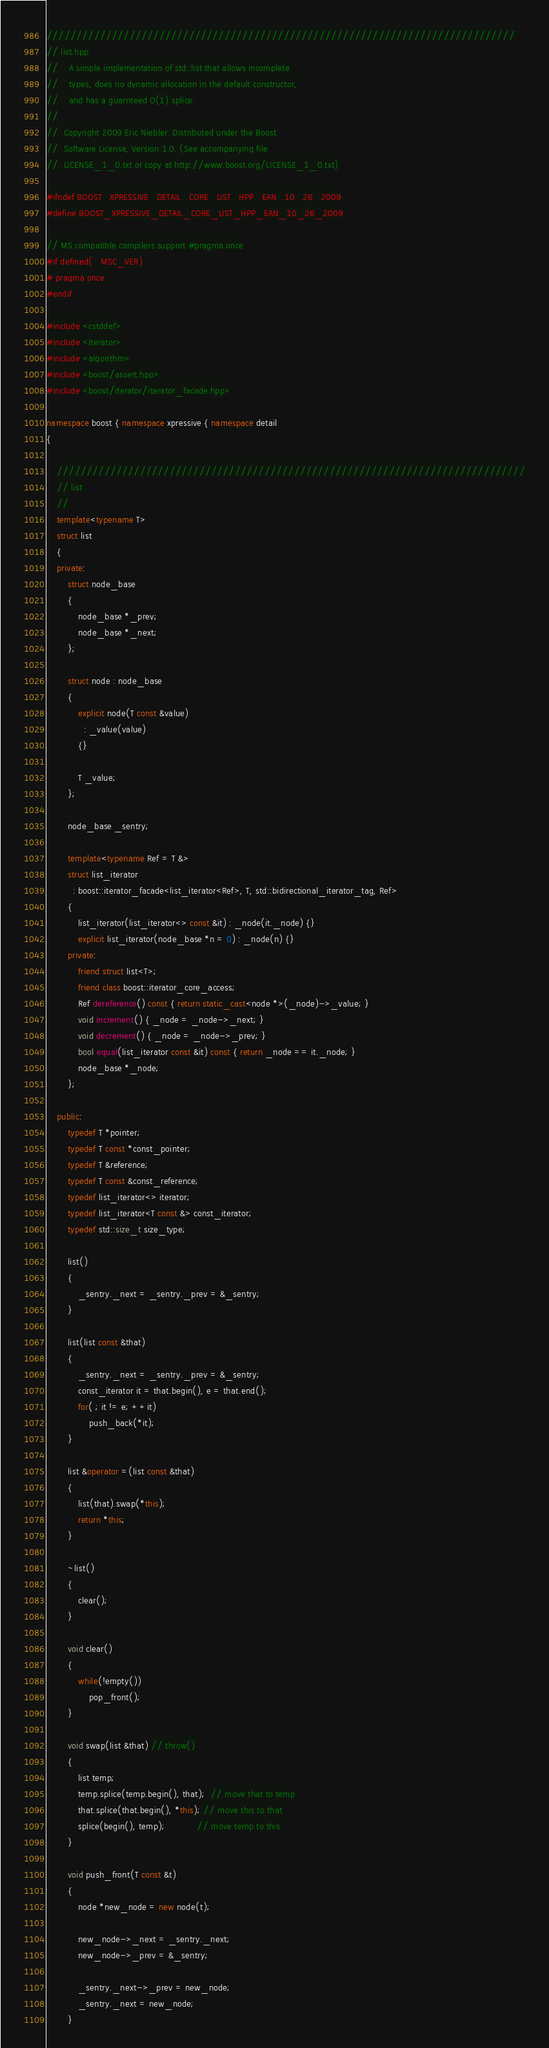<code> <loc_0><loc_0><loc_500><loc_500><_C++_>///////////////////////////////////////////////////////////////////////////////
// list.hpp
//    A simple implementation of std::list that allows incomplete
//    types, does no dynamic allocation in the default constructor,
//    and has a guarnteed O(1) splice.
//
//  Copyright 2009 Eric Niebler. Distributed under the Boost
//  Software License, Version 1.0. (See accompanying file
//  LICENSE_1_0.txt or copy at http://www.boost.org/LICENSE_1_0.txt)

#ifndef BOOST_XPRESSIVE_DETAIL_CORE_LIST_HPP_EAN_10_26_2009
#define BOOST_XPRESSIVE_DETAIL_CORE_LIST_HPP_EAN_10_26_2009

// MS compatible compilers support #pragma once
#if defined(_MSC_VER)
# pragma once
#endif

#include <cstddef>
#include <iterator>
#include <algorithm>
#include <boost/assert.hpp>
#include <boost/iterator/iterator_facade.hpp>

namespace boost { namespace xpressive { namespace detail
{

    ///////////////////////////////////////////////////////////////////////////////
    // list
    //
    template<typename T>
    struct list
    {
    private:
        struct node_base
        {
            node_base *_prev;
            node_base *_next;
        };

        struct node : node_base
        {
            explicit node(T const &value)
              : _value(value)
            {}

            T _value;
        };

        node_base _sentry;

        template<typename Ref = T &>
        struct list_iterator
          : boost::iterator_facade<list_iterator<Ref>, T, std::bidirectional_iterator_tag, Ref>
        {
            list_iterator(list_iterator<> const &it) : _node(it._node) {}
            explicit list_iterator(node_base *n = 0) : _node(n) {}
        private:
            friend struct list<T>;
            friend class boost::iterator_core_access;
            Ref dereference() const { return static_cast<node *>(_node)->_value; }
            void increment() { _node = _node->_next; }
            void decrement() { _node = _node->_prev; }
            bool equal(list_iterator const &it) const { return _node == it._node; }
            node_base *_node;
        };

    public:
        typedef T *pointer;
        typedef T const *const_pointer;
        typedef T &reference;
        typedef T const &const_reference;
        typedef list_iterator<> iterator;
        typedef list_iterator<T const &> const_iterator;
        typedef std::size_t size_type;

        list()
        {
            _sentry._next = _sentry._prev = &_sentry;
        }

        list(list const &that)
        {
            _sentry._next = _sentry._prev = &_sentry;
            const_iterator it = that.begin(), e = that.end();
            for( ; it != e; ++it)
                push_back(*it);
        }

        list &operator =(list const &that)
        {
            list(that).swap(*this);
            return *this;
        }

        ~list()
        {
            clear();
        }

        void clear()
        {
            while(!empty())
                pop_front();
        }

        void swap(list &that) // throw()
        {
            list temp;
            temp.splice(temp.begin(), that);  // move that to temp
            that.splice(that.begin(), *this); // move this to that
            splice(begin(), temp);            // move temp to this
        }

        void push_front(T const &t)
        {
            node *new_node = new node(t);

            new_node->_next = _sentry._next;
            new_node->_prev = &_sentry;

            _sentry._next->_prev = new_node;
            _sentry._next = new_node;
        }
</code> 